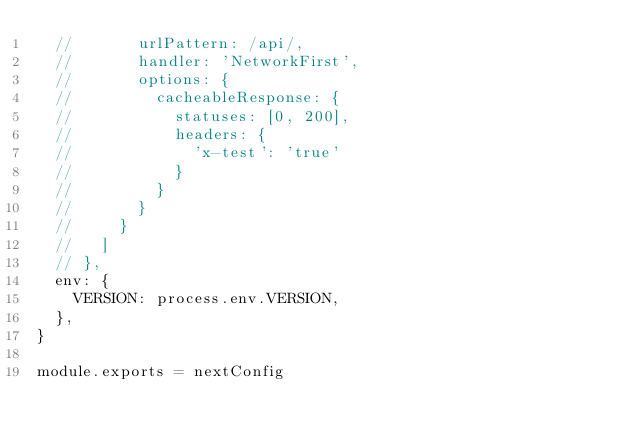Convert code to text. <code><loc_0><loc_0><loc_500><loc_500><_JavaScript_>  //       urlPattern: /api/,
  //       handler: 'NetworkFirst',
  //       options: {
  //         cacheableResponse: {
  //           statuses: [0, 200],
  //           headers: {
  //             'x-test': 'true'
  //           }
  //         }
  //       }
  //     }
  //   ]
  // },
  env: {
    VERSION: process.env.VERSION,
  },
}

module.exports = nextConfig</code> 